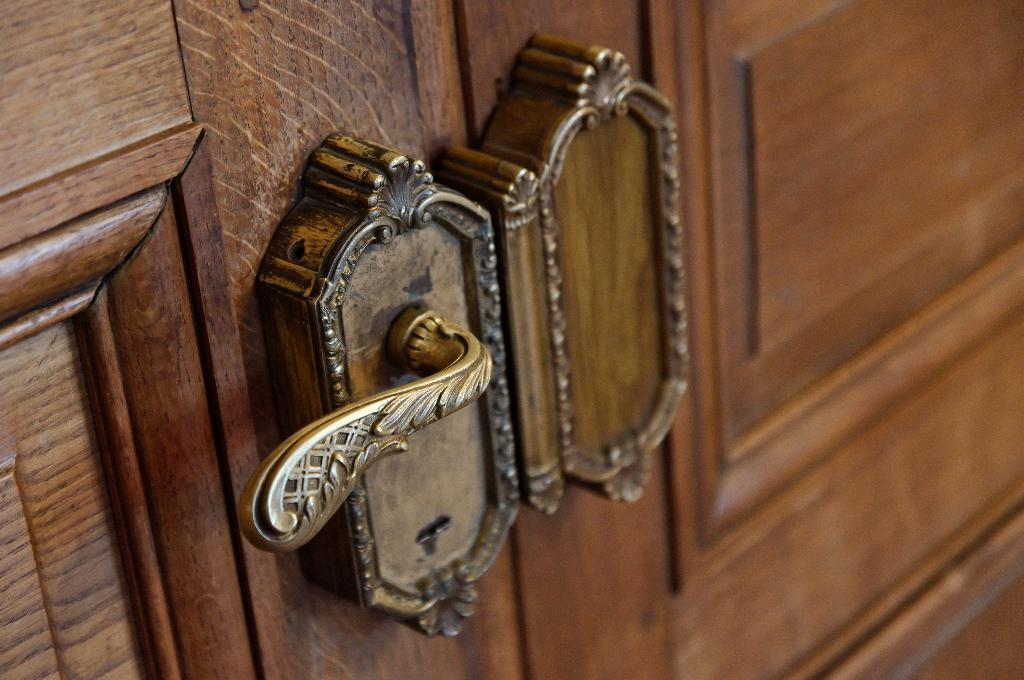What is present in the image that serves as an entry point? There is a door in the image. Can you describe a specific feature of the door? There is a door handle on the left side of the door. What type of expert is standing next to the door in the image? There is no expert present in the image; it only features a door and a door handle. What shape is the door handle in the image? The provided facts do not specify the shape of the door handle, so it cannot be determined from the image. 